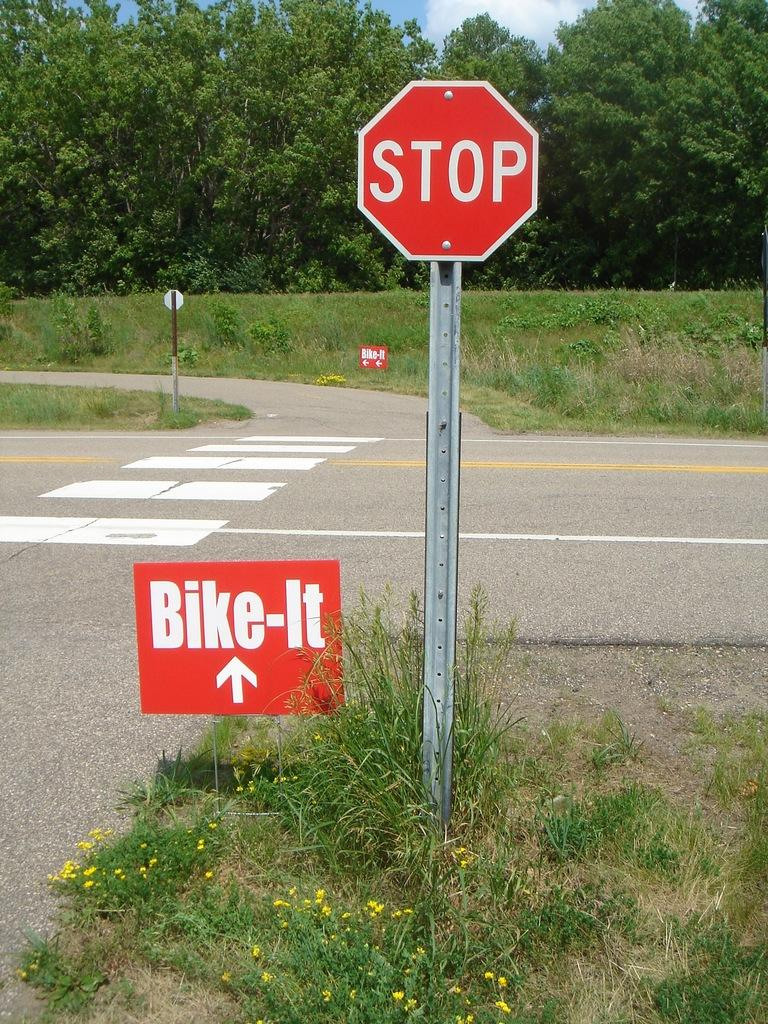<image>
Write a terse but informative summary of the picture. A stop sign stands above another sign which says bike it on a grassy intersection. 